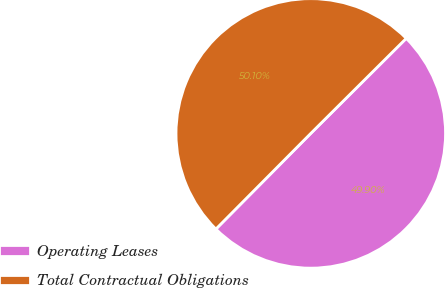<chart> <loc_0><loc_0><loc_500><loc_500><pie_chart><fcel>Operating Leases<fcel>Total Contractual Obligations<nl><fcel>49.9%<fcel>50.1%<nl></chart> 